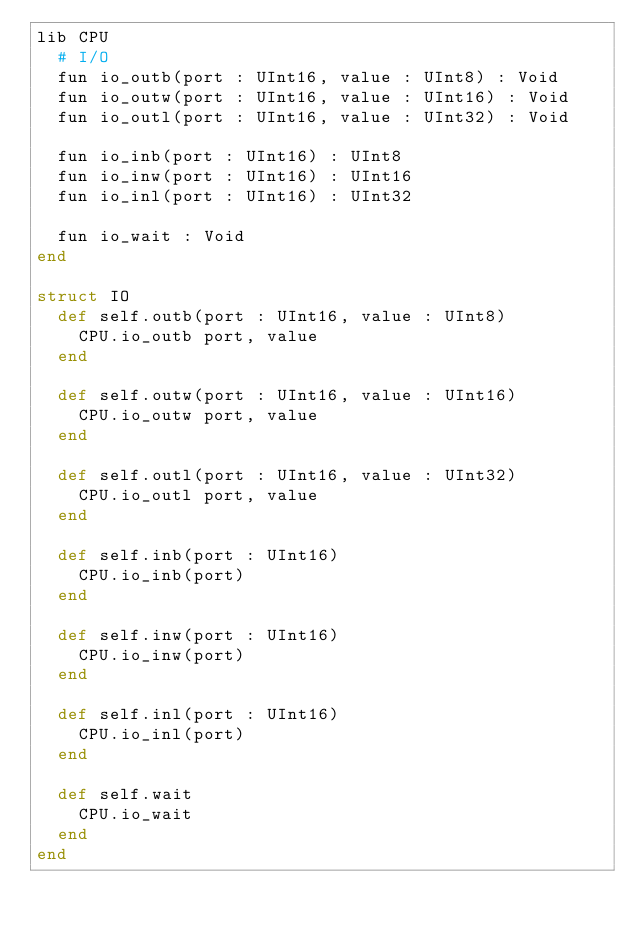<code> <loc_0><loc_0><loc_500><loc_500><_Crystal_>lib CPU
  # I/O
  fun io_outb(port : UInt16, value : UInt8) : Void
  fun io_outw(port : UInt16, value : UInt16) : Void
  fun io_outl(port : UInt16, value : UInt32) : Void

  fun io_inb(port : UInt16) : UInt8
  fun io_inw(port : UInt16) : UInt16
  fun io_inl(port : UInt16) : UInt32

  fun io_wait : Void
end

struct IO
  def self.outb(port : UInt16, value : UInt8)
    CPU.io_outb port, value
  end

  def self.outw(port : UInt16, value : UInt16)
    CPU.io_outw port, value
  end

  def self.outl(port : UInt16, value : UInt32)
    CPU.io_outl port, value
  end

  def self.inb(port : UInt16)
    CPU.io_inb(port)
  end

  def self.inw(port : UInt16)
    CPU.io_inw(port)
  end

  def self.inl(port : UInt16)
    CPU.io_inl(port)
  end

  def self.wait
    CPU.io_wait
  end
end
</code> 